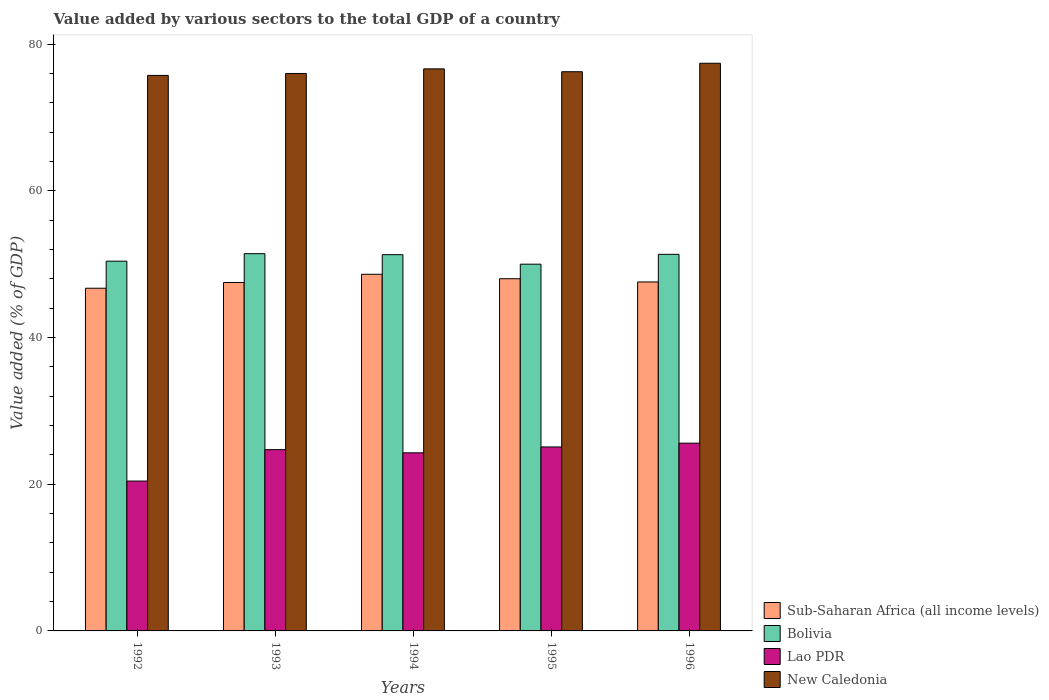How many different coloured bars are there?
Keep it short and to the point. 4. How many groups of bars are there?
Your answer should be very brief. 5. How many bars are there on the 1st tick from the right?
Make the answer very short. 4. What is the label of the 3rd group of bars from the left?
Keep it short and to the point. 1994. What is the value added by various sectors to the total GDP in Sub-Saharan Africa (all income levels) in 1995?
Offer a terse response. 48.02. Across all years, what is the maximum value added by various sectors to the total GDP in Lao PDR?
Provide a short and direct response. 25.6. Across all years, what is the minimum value added by various sectors to the total GDP in Bolivia?
Keep it short and to the point. 50. In which year was the value added by various sectors to the total GDP in New Caledonia maximum?
Offer a very short reply. 1996. In which year was the value added by various sectors to the total GDP in Lao PDR minimum?
Ensure brevity in your answer.  1992. What is the total value added by various sectors to the total GDP in Bolivia in the graph?
Keep it short and to the point. 254.5. What is the difference between the value added by various sectors to the total GDP in Bolivia in 1993 and that in 1995?
Your response must be concise. 1.43. What is the difference between the value added by various sectors to the total GDP in Lao PDR in 1994 and the value added by various sectors to the total GDP in New Caledonia in 1995?
Give a very brief answer. -51.96. What is the average value added by various sectors to the total GDP in Sub-Saharan Africa (all income levels) per year?
Your response must be concise. 47.69. In the year 1994, what is the difference between the value added by various sectors to the total GDP in Lao PDR and value added by various sectors to the total GDP in Bolivia?
Give a very brief answer. -27.02. In how many years, is the value added by various sectors to the total GDP in Bolivia greater than 76 %?
Offer a very short reply. 0. What is the ratio of the value added by various sectors to the total GDP in Lao PDR in 1994 to that in 1996?
Your response must be concise. 0.95. What is the difference between the highest and the second highest value added by various sectors to the total GDP in Sub-Saharan Africa (all income levels)?
Offer a terse response. 0.61. What is the difference between the highest and the lowest value added by various sectors to the total GDP in Sub-Saharan Africa (all income levels)?
Keep it short and to the point. 1.9. Is it the case that in every year, the sum of the value added by various sectors to the total GDP in New Caledonia and value added by various sectors to the total GDP in Lao PDR is greater than the sum of value added by various sectors to the total GDP in Sub-Saharan Africa (all income levels) and value added by various sectors to the total GDP in Bolivia?
Provide a short and direct response. No. What does the 4th bar from the left in 1994 represents?
Your response must be concise. New Caledonia. What does the 1st bar from the right in 1995 represents?
Provide a short and direct response. New Caledonia. Are all the bars in the graph horizontal?
Provide a succinct answer. No. What is the difference between two consecutive major ticks on the Y-axis?
Provide a succinct answer. 20. Does the graph contain any zero values?
Make the answer very short. No. How are the legend labels stacked?
Make the answer very short. Vertical. What is the title of the graph?
Your answer should be compact. Value added by various sectors to the total GDP of a country. What is the label or title of the Y-axis?
Provide a succinct answer. Value added (% of GDP). What is the Value added (% of GDP) in Sub-Saharan Africa (all income levels) in 1992?
Your answer should be very brief. 46.72. What is the Value added (% of GDP) in Bolivia in 1992?
Your answer should be very brief. 50.41. What is the Value added (% of GDP) in Lao PDR in 1992?
Offer a terse response. 20.43. What is the Value added (% of GDP) in New Caledonia in 1992?
Offer a very short reply. 75.74. What is the Value added (% of GDP) in Sub-Saharan Africa (all income levels) in 1993?
Give a very brief answer. 47.5. What is the Value added (% of GDP) of Bolivia in 1993?
Your answer should be compact. 51.44. What is the Value added (% of GDP) of Lao PDR in 1993?
Give a very brief answer. 24.72. What is the Value added (% of GDP) of New Caledonia in 1993?
Keep it short and to the point. 76. What is the Value added (% of GDP) in Sub-Saharan Africa (all income levels) in 1994?
Give a very brief answer. 48.63. What is the Value added (% of GDP) in Bolivia in 1994?
Make the answer very short. 51.3. What is the Value added (% of GDP) of Lao PDR in 1994?
Provide a short and direct response. 24.28. What is the Value added (% of GDP) of New Caledonia in 1994?
Offer a terse response. 76.63. What is the Value added (% of GDP) of Sub-Saharan Africa (all income levels) in 1995?
Offer a terse response. 48.02. What is the Value added (% of GDP) of Bolivia in 1995?
Provide a succinct answer. 50. What is the Value added (% of GDP) in Lao PDR in 1995?
Your answer should be compact. 25.08. What is the Value added (% of GDP) of New Caledonia in 1995?
Give a very brief answer. 76.24. What is the Value added (% of GDP) of Sub-Saharan Africa (all income levels) in 1996?
Offer a very short reply. 47.58. What is the Value added (% of GDP) of Bolivia in 1996?
Offer a very short reply. 51.35. What is the Value added (% of GDP) in Lao PDR in 1996?
Keep it short and to the point. 25.6. What is the Value added (% of GDP) of New Caledonia in 1996?
Provide a succinct answer. 77.4. Across all years, what is the maximum Value added (% of GDP) of Sub-Saharan Africa (all income levels)?
Your answer should be compact. 48.63. Across all years, what is the maximum Value added (% of GDP) in Bolivia?
Offer a terse response. 51.44. Across all years, what is the maximum Value added (% of GDP) of Lao PDR?
Provide a short and direct response. 25.6. Across all years, what is the maximum Value added (% of GDP) in New Caledonia?
Provide a succinct answer. 77.4. Across all years, what is the minimum Value added (% of GDP) in Sub-Saharan Africa (all income levels)?
Your response must be concise. 46.72. Across all years, what is the minimum Value added (% of GDP) in Bolivia?
Your answer should be very brief. 50. Across all years, what is the minimum Value added (% of GDP) of Lao PDR?
Your answer should be compact. 20.43. Across all years, what is the minimum Value added (% of GDP) of New Caledonia?
Make the answer very short. 75.74. What is the total Value added (% of GDP) of Sub-Saharan Africa (all income levels) in the graph?
Provide a short and direct response. 238.46. What is the total Value added (% of GDP) of Bolivia in the graph?
Offer a very short reply. 254.5. What is the total Value added (% of GDP) of Lao PDR in the graph?
Make the answer very short. 120.12. What is the total Value added (% of GDP) in New Caledonia in the graph?
Provide a short and direct response. 382.02. What is the difference between the Value added (% of GDP) of Sub-Saharan Africa (all income levels) in 1992 and that in 1993?
Your answer should be very brief. -0.78. What is the difference between the Value added (% of GDP) of Bolivia in 1992 and that in 1993?
Give a very brief answer. -1.02. What is the difference between the Value added (% of GDP) of Lao PDR in 1992 and that in 1993?
Make the answer very short. -4.28. What is the difference between the Value added (% of GDP) in New Caledonia in 1992 and that in 1993?
Your answer should be very brief. -0.26. What is the difference between the Value added (% of GDP) of Sub-Saharan Africa (all income levels) in 1992 and that in 1994?
Provide a succinct answer. -1.9. What is the difference between the Value added (% of GDP) in Bolivia in 1992 and that in 1994?
Give a very brief answer. -0.88. What is the difference between the Value added (% of GDP) of Lao PDR in 1992 and that in 1994?
Offer a terse response. -3.85. What is the difference between the Value added (% of GDP) in New Caledonia in 1992 and that in 1994?
Ensure brevity in your answer.  -0.89. What is the difference between the Value added (% of GDP) in Sub-Saharan Africa (all income levels) in 1992 and that in 1995?
Your answer should be compact. -1.3. What is the difference between the Value added (% of GDP) in Bolivia in 1992 and that in 1995?
Keep it short and to the point. 0.41. What is the difference between the Value added (% of GDP) in Lao PDR in 1992 and that in 1995?
Provide a short and direct response. -4.65. What is the difference between the Value added (% of GDP) of New Caledonia in 1992 and that in 1995?
Provide a succinct answer. -0.5. What is the difference between the Value added (% of GDP) of Sub-Saharan Africa (all income levels) in 1992 and that in 1996?
Provide a short and direct response. -0.86. What is the difference between the Value added (% of GDP) in Bolivia in 1992 and that in 1996?
Ensure brevity in your answer.  -0.93. What is the difference between the Value added (% of GDP) in Lao PDR in 1992 and that in 1996?
Offer a very short reply. -5.17. What is the difference between the Value added (% of GDP) of New Caledonia in 1992 and that in 1996?
Make the answer very short. -1.66. What is the difference between the Value added (% of GDP) of Sub-Saharan Africa (all income levels) in 1993 and that in 1994?
Offer a very short reply. -1.12. What is the difference between the Value added (% of GDP) of Bolivia in 1993 and that in 1994?
Make the answer very short. 0.14. What is the difference between the Value added (% of GDP) of Lao PDR in 1993 and that in 1994?
Give a very brief answer. 0.43. What is the difference between the Value added (% of GDP) in New Caledonia in 1993 and that in 1994?
Give a very brief answer. -0.63. What is the difference between the Value added (% of GDP) in Sub-Saharan Africa (all income levels) in 1993 and that in 1995?
Offer a very short reply. -0.52. What is the difference between the Value added (% of GDP) of Bolivia in 1993 and that in 1995?
Provide a succinct answer. 1.43. What is the difference between the Value added (% of GDP) of Lao PDR in 1993 and that in 1995?
Your answer should be very brief. -0.37. What is the difference between the Value added (% of GDP) in New Caledonia in 1993 and that in 1995?
Offer a terse response. -0.24. What is the difference between the Value added (% of GDP) of Sub-Saharan Africa (all income levels) in 1993 and that in 1996?
Make the answer very short. -0.08. What is the difference between the Value added (% of GDP) of Bolivia in 1993 and that in 1996?
Your response must be concise. 0.09. What is the difference between the Value added (% of GDP) in Lao PDR in 1993 and that in 1996?
Ensure brevity in your answer.  -0.88. What is the difference between the Value added (% of GDP) of New Caledonia in 1993 and that in 1996?
Provide a succinct answer. -1.39. What is the difference between the Value added (% of GDP) in Sub-Saharan Africa (all income levels) in 1994 and that in 1995?
Give a very brief answer. 0.61. What is the difference between the Value added (% of GDP) in Bolivia in 1994 and that in 1995?
Make the answer very short. 1.3. What is the difference between the Value added (% of GDP) in Lao PDR in 1994 and that in 1995?
Provide a succinct answer. -0.8. What is the difference between the Value added (% of GDP) in New Caledonia in 1994 and that in 1995?
Keep it short and to the point. 0.39. What is the difference between the Value added (% of GDP) in Sub-Saharan Africa (all income levels) in 1994 and that in 1996?
Your answer should be very brief. 1.05. What is the difference between the Value added (% of GDP) in Bolivia in 1994 and that in 1996?
Offer a very short reply. -0.05. What is the difference between the Value added (% of GDP) in Lao PDR in 1994 and that in 1996?
Give a very brief answer. -1.32. What is the difference between the Value added (% of GDP) in New Caledonia in 1994 and that in 1996?
Make the answer very short. -0.76. What is the difference between the Value added (% of GDP) in Sub-Saharan Africa (all income levels) in 1995 and that in 1996?
Keep it short and to the point. 0.44. What is the difference between the Value added (% of GDP) of Bolivia in 1995 and that in 1996?
Your answer should be very brief. -1.34. What is the difference between the Value added (% of GDP) in Lao PDR in 1995 and that in 1996?
Provide a succinct answer. -0.52. What is the difference between the Value added (% of GDP) of New Caledonia in 1995 and that in 1996?
Make the answer very short. -1.15. What is the difference between the Value added (% of GDP) in Sub-Saharan Africa (all income levels) in 1992 and the Value added (% of GDP) in Bolivia in 1993?
Provide a succinct answer. -4.71. What is the difference between the Value added (% of GDP) of Sub-Saharan Africa (all income levels) in 1992 and the Value added (% of GDP) of Lao PDR in 1993?
Your answer should be compact. 22.01. What is the difference between the Value added (% of GDP) of Sub-Saharan Africa (all income levels) in 1992 and the Value added (% of GDP) of New Caledonia in 1993?
Offer a very short reply. -29.28. What is the difference between the Value added (% of GDP) in Bolivia in 1992 and the Value added (% of GDP) in Lao PDR in 1993?
Make the answer very short. 25.7. What is the difference between the Value added (% of GDP) in Bolivia in 1992 and the Value added (% of GDP) in New Caledonia in 1993?
Offer a terse response. -25.59. What is the difference between the Value added (% of GDP) in Lao PDR in 1992 and the Value added (% of GDP) in New Caledonia in 1993?
Provide a short and direct response. -55.57. What is the difference between the Value added (% of GDP) of Sub-Saharan Africa (all income levels) in 1992 and the Value added (% of GDP) of Bolivia in 1994?
Provide a succinct answer. -4.58. What is the difference between the Value added (% of GDP) of Sub-Saharan Africa (all income levels) in 1992 and the Value added (% of GDP) of Lao PDR in 1994?
Give a very brief answer. 22.44. What is the difference between the Value added (% of GDP) of Sub-Saharan Africa (all income levels) in 1992 and the Value added (% of GDP) of New Caledonia in 1994?
Keep it short and to the point. -29.91. What is the difference between the Value added (% of GDP) of Bolivia in 1992 and the Value added (% of GDP) of Lao PDR in 1994?
Offer a very short reply. 26.13. What is the difference between the Value added (% of GDP) in Bolivia in 1992 and the Value added (% of GDP) in New Caledonia in 1994?
Provide a short and direct response. -26.22. What is the difference between the Value added (% of GDP) in Lao PDR in 1992 and the Value added (% of GDP) in New Caledonia in 1994?
Your answer should be very brief. -56.2. What is the difference between the Value added (% of GDP) in Sub-Saharan Africa (all income levels) in 1992 and the Value added (% of GDP) in Bolivia in 1995?
Your response must be concise. -3.28. What is the difference between the Value added (% of GDP) in Sub-Saharan Africa (all income levels) in 1992 and the Value added (% of GDP) in Lao PDR in 1995?
Your response must be concise. 21.64. What is the difference between the Value added (% of GDP) of Sub-Saharan Africa (all income levels) in 1992 and the Value added (% of GDP) of New Caledonia in 1995?
Provide a succinct answer. -29.52. What is the difference between the Value added (% of GDP) of Bolivia in 1992 and the Value added (% of GDP) of Lao PDR in 1995?
Provide a succinct answer. 25.33. What is the difference between the Value added (% of GDP) of Bolivia in 1992 and the Value added (% of GDP) of New Caledonia in 1995?
Give a very brief answer. -25.83. What is the difference between the Value added (% of GDP) in Lao PDR in 1992 and the Value added (% of GDP) in New Caledonia in 1995?
Offer a very short reply. -55.81. What is the difference between the Value added (% of GDP) of Sub-Saharan Africa (all income levels) in 1992 and the Value added (% of GDP) of Bolivia in 1996?
Keep it short and to the point. -4.62. What is the difference between the Value added (% of GDP) in Sub-Saharan Africa (all income levels) in 1992 and the Value added (% of GDP) in Lao PDR in 1996?
Your response must be concise. 21.12. What is the difference between the Value added (% of GDP) in Sub-Saharan Africa (all income levels) in 1992 and the Value added (% of GDP) in New Caledonia in 1996?
Offer a terse response. -30.67. What is the difference between the Value added (% of GDP) of Bolivia in 1992 and the Value added (% of GDP) of Lao PDR in 1996?
Your response must be concise. 24.81. What is the difference between the Value added (% of GDP) in Bolivia in 1992 and the Value added (% of GDP) in New Caledonia in 1996?
Offer a terse response. -26.98. What is the difference between the Value added (% of GDP) in Lao PDR in 1992 and the Value added (% of GDP) in New Caledonia in 1996?
Offer a very short reply. -56.96. What is the difference between the Value added (% of GDP) of Sub-Saharan Africa (all income levels) in 1993 and the Value added (% of GDP) of Bolivia in 1994?
Ensure brevity in your answer.  -3.8. What is the difference between the Value added (% of GDP) in Sub-Saharan Africa (all income levels) in 1993 and the Value added (% of GDP) in Lao PDR in 1994?
Offer a very short reply. 23.22. What is the difference between the Value added (% of GDP) of Sub-Saharan Africa (all income levels) in 1993 and the Value added (% of GDP) of New Caledonia in 1994?
Keep it short and to the point. -29.13. What is the difference between the Value added (% of GDP) of Bolivia in 1993 and the Value added (% of GDP) of Lao PDR in 1994?
Provide a succinct answer. 27.15. What is the difference between the Value added (% of GDP) of Bolivia in 1993 and the Value added (% of GDP) of New Caledonia in 1994?
Give a very brief answer. -25.2. What is the difference between the Value added (% of GDP) of Lao PDR in 1993 and the Value added (% of GDP) of New Caledonia in 1994?
Offer a very short reply. -51.92. What is the difference between the Value added (% of GDP) in Sub-Saharan Africa (all income levels) in 1993 and the Value added (% of GDP) in Bolivia in 1995?
Your answer should be very brief. -2.5. What is the difference between the Value added (% of GDP) of Sub-Saharan Africa (all income levels) in 1993 and the Value added (% of GDP) of Lao PDR in 1995?
Keep it short and to the point. 22.42. What is the difference between the Value added (% of GDP) in Sub-Saharan Africa (all income levels) in 1993 and the Value added (% of GDP) in New Caledonia in 1995?
Make the answer very short. -28.74. What is the difference between the Value added (% of GDP) in Bolivia in 1993 and the Value added (% of GDP) in Lao PDR in 1995?
Ensure brevity in your answer.  26.35. What is the difference between the Value added (% of GDP) of Bolivia in 1993 and the Value added (% of GDP) of New Caledonia in 1995?
Provide a short and direct response. -24.81. What is the difference between the Value added (% of GDP) in Lao PDR in 1993 and the Value added (% of GDP) in New Caledonia in 1995?
Keep it short and to the point. -51.53. What is the difference between the Value added (% of GDP) in Sub-Saharan Africa (all income levels) in 1993 and the Value added (% of GDP) in Bolivia in 1996?
Offer a terse response. -3.84. What is the difference between the Value added (% of GDP) of Sub-Saharan Africa (all income levels) in 1993 and the Value added (% of GDP) of Lao PDR in 1996?
Your response must be concise. 21.9. What is the difference between the Value added (% of GDP) of Sub-Saharan Africa (all income levels) in 1993 and the Value added (% of GDP) of New Caledonia in 1996?
Give a very brief answer. -29.89. What is the difference between the Value added (% of GDP) of Bolivia in 1993 and the Value added (% of GDP) of Lao PDR in 1996?
Offer a very short reply. 25.84. What is the difference between the Value added (% of GDP) of Bolivia in 1993 and the Value added (% of GDP) of New Caledonia in 1996?
Keep it short and to the point. -25.96. What is the difference between the Value added (% of GDP) in Lao PDR in 1993 and the Value added (% of GDP) in New Caledonia in 1996?
Make the answer very short. -52.68. What is the difference between the Value added (% of GDP) in Sub-Saharan Africa (all income levels) in 1994 and the Value added (% of GDP) in Bolivia in 1995?
Your response must be concise. -1.38. What is the difference between the Value added (% of GDP) of Sub-Saharan Africa (all income levels) in 1994 and the Value added (% of GDP) of Lao PDR in 1995?
Your answer should be compact. 23.54. What is the difference between the Value added (% of GDP) of Sub-Saharan Africa (all income levels) in 1994 and the Value added (% of GDP) of New Caledonia in 1995?
Your answer should be very brief. -27.62. What is the difference between the Value added (% of GDP) of Bolivia in 1994 and the Value added (% of GDP) of Lao PDR in 1995?
Give a very brief answer. 26.22. What is the difference between the Value added (% of GDP) of Bolivia in 1994 and the Value added (% of GDP) of New Caledonia in 1995?
Provide a short and direct response. -24.94. What is the difference between the Value added (% of GDP) of Lao PDR in 1994 and the Value added (% of GDP) of New Caledonia in 1995?
Give a very brief answer. -51.96. What is the difference between the Value added (% of GDP) of Sub-Saharan Africa (all income levels) in 1994 and the Value added (% of GDP) of Bolivia in 1996?
Give a very brief answer. -2.72. What is the difference between the Value added (% of GDP) in Sub-Saharan Africa (all income levels) in 1994 and the Value added (% of GDP) in Lao PDR in 1996?
Keep it short and to the point. 23.03. What is the difference between the Value added (% of GDP) of Sub-Saharan Africa (all income levels) in 1994 and the Value added (% of GDP) of New Caledonia in 1996?
Give a very brief answer. -28.77. What is the difference between the Value added (% of GDP) of Bolivia in 1994 and the Value added (% of GDP) of Lao PDR in 1996?
Your response must be concise. 25.7. What is the difference between the Value added (% of GDP) in Bolivia in 1994 and the Value added (% of GDP) in New Caledonia in 1996?
Provide a short and direct response. -26.1. What is the difference between the Value added (% of GDP) in Lao PDR in 1994 and the Value added (% of GDP) in New Caledonia in 1996?
Provide a short and direct response. -53.11. What is the difference between the Value added (% of GDP) in Sub-Saharan Africa (all income levels) in 1995 and the Value added (% of GDP) in Bolivia in 1996?
Provide a succinct answer. -3.33. What is the difference between the Value added (% of GDP) in Sub-Saharan Africa (all income levels) in 1995 and the Value added (% of GDP) in Lao PDR in 1996?
Your answer should be compact. 22.42. What is the difference between the Value added (% of GDP) of Sub-Saharan Africa (all income levels) in 1995 and the Value added (% of GDP) of New Caledonia in 1996?
Give a very brief answer. -29.38. What is the difference between the Value added (% of GDP) of Bolivia in 1995 and the Value added (% of GDP) of Lao PDR in 1996?
Ensure brevity in your answer.  24.4. What is the difference between the Value added (% of GDP) of Bolivia in 1995 and the Value added (% of GDP) of New Caledonia in 1996?
Ensure brevity in your answer.  -27.39. What is the difference between the Value added (% of GDP) in Lao PDR in 1995 and the Value added (% of GDP) in New Caledonia in 1996?
Ensure brevity in your answer.  -52.31. What is the average Value added (% of GDP) of Sub-Saharan Africa (all income levels) per year?
Give a very brief answer. 47.69. What is the average Value added (% of GDP) of Bolivia per year?
Provide a succinct answer. 50.9. What is the average Value added (% of GDP) in Lao PDR per year?
Make the answer very short. 24.02. What is the average Value added (% of GDP) of New Caledonia per year?
Your response must be concise. 76.4. In the year 1992, what is the difference between the Value added (% of GDP) of Sub-Saharan Africa (all income levels) and Value added (% of GDP) of Bolivia?
Your answer should be very brief. -3.69. In the year 1992, what is the difference between the Value added (% of GDP) of Sub-Saharan Africa (all income levels) and Value added (% of GDP) of Lao PDR?
Your answer should be compact. 26.29. In the year 1992, what is the difference between the Value added (% of GDP) in Sub-Saharan Africa (all income levels) and Value added (% of GDP) in New Caledonia?
Offer a terse response. -29.02. In the year 1992, what is the difference between the Value added (% of GDP) of Bolivia and Value added (% of GDP) of Lao PDR?
Provide a short and direct response. 29.98. In the year 1992, what is the difference between the Value added (% of GDP) in Bolivia and Value added (% of GDP) in New Caledonia?
Provide a succinct answer. -25.33. In the year 1992, what is the difference between the Value added (% of GDP) of Lao PDR and Value added (% of GDP) of New Caledonia?
Make the answer very short. -55.31. In the year 1993, what is the difference between the Value added (% of GDP) of Sub-Saharan Africa (all income levels) and Value added (% of GDP) of Bolivia?
Ensure brevity in your answer.  -3.93. In the year 1993, what is the difference between the Value added (% of GDP) of Sub-Saharan Africa (all income levels) and Value added (% of GDP) of Lao PDR?
Your answer should be compact. 22.79. In the year 1993, what is the difference between the Value added (% of GDP) of Sub-Saharan Africa (all income levels) and Value added (% of GDP) of New Caledonia?
Give a very brief answer. -28.5. In the year 1993, what is the difference between the Value added (% of GDP) of Bolivia and Value added (% of GDP) of Lao PDR?
Your answer should be very brief. 26.72. In the year 1993, what is the difference between the Value added (% of GDP) of Bolivia and Value added (% of GDP) of New Caledonia?
Give a very brief answer. -24.57. In the year 1993, what is the difference between the Value added (% of GDP) of Lao PDR and Value added (% of GDP) of New Caledonia?
Provide a short and direct response. -51.29. In the year 1994, what is the difference between the Value added (% of GDP) of Sub-Saharan Africa (all income levels) and Value added (% of GDP) of Bolivia?
Offer a terse response. -2.67. In the year 1994, what is the difference between the Value added (% of GDP) in Sub-Saharan Africa (all income levels) and Value added (% of GDP) in Lao PDR?
Make the answer very short. 24.34. In the year 1994, what is the difference between the Value added (% of GDP) in Sub-Saharan Africa (all income levels) and Value added (% of GDP) in New Caledonia?
Keep it short and to the point. -28.01. In the year 1994, what is the difference between the Value added (% of GDP) of Bolivia and Value added (% of GDP) of Lao PDR?
Keep it short and to the point. 27.02. In the year 1994, what is the difference between the Value added (% of GDP) in Bolivia and Value added (% of GDP) in New Caledonia?
Your answer should be very brief. -25.33. In the year 1994, what is the difference between the Value added (% of GDP) in Lao PDR and Value added (% of GDP) in New Caledonia?
Give a very brief answer. -52.35. In the year 1995, what is the difference between the Value added (% of GDP) of Sub-Saharan Africa (all income levels) and Value added (% of GDP) of Bolivia?
Keep it short and to the point. -1.98. In the year 1995, what is the difference between the Value added (% of GDP) in Sub-Saharan Africa (all income levels) and Value added (% of GDP) in Lao PDR?
Provide a succinct answer. 22.94. In the year 1995, what is the difference between the Value added (% of GDP) in Sub-Saharan Africa (all income levels) and Value added (% of GDP) in New Caledonia?
Provide a short and direct response. -28.22. In the year 1995, what is the difference between the Value added (% of GDP) in Bolivia and Value added (% of GDP) in Lao PDR?
Offer a terse response. 24.92. In the year 1995, what is the difference between the Value added (% of GDP) in Bolivia and Value added (% of GDP) in New Caledonia?
Your answer should be very brief. -26.24. In the year 1995, what is the difference between the Value added (% of GDP) in Lao PDR and Value added (% of GDP) in New Caledonia?
Provide a succinct answer. -51.16. In the year 1996, what is the difference between the Value added (% of GDP) of Sub-Saharan Africa (all income levels) and Value added (% of GDP) of Bolivia?
Offer a very short reply. -3.77. In the year 1996, what is the difference between the Value added (% of GDP) in Sub-Saharan Africa (all income levels) and Value added (% of GDP) in Lao PDR?
Offer a terse response. 21.98. In the year 1996, what is the difference between the Value added (% of GDP) of Sub-Saharan Africa (all income levels) and Value added (% of GDP) of New Caledonia?
Your answer should be very brief. -29.82. In the year 1996, what is the difference between the Value added (% of GDP) in Bolivia and Value added (% of GDP) in Lao PDR?
Offer a very short reply. 25.75. In the year 1996, what is the difference between the Value added (% of GDP) in Bolivia and Value added (% of GDP) in New Caledonia?
Give a very brief answer. -26.05. In the year 1996, what is the difference between the Value added (% of GDP) of Lao PDR and Value added (% of GDP) of New Caledonia?
Make the answer very short. -51.8. What is the ratio of the Value added (% of GDP) of Sub-Saharan Africa (all income levels) in 1992 to that in 1993?
Give a very brief answer. 0.98. What is the ratio of the Value added (% of GDP) in Bolivia in 1992 to that in 1993?
Ensure brevity in your answer.  0.98. What is the ratio of the Value added (% of GDP) in Lao PDR in 1992 to that in 1993?
Provide a short and direct response. 0.83. What is the ratio of the Value added (% of GDP) in New Caledonia in 1992 to that in 1993?
Your answer should be very brief. 1. What is the ratio of the Value added (% of GDP) in Sub-Saharan Africa (all income levels) in 1992 to that in 1994?
Give a very brief answer. 0.96. What is the ratio of the Value added (% of GDP) of Bolivia in 1992 to that in 1994?
Keep it short and to the point. 0.98. What is the ratio of the Value added (% of GDP) in Lao PDR in 1992 to that in 1994?
Provide a short and direct response. 0.84. What is the ratio of the Value added (% of GDP) of New Caledonia in 1992 to that in 1994?
Ensure brevity in your answer.  0.99. What is the ratio of the Value added (% of GDP) in Sub-Saharan Africa (all income levels) in 1992 to that in 1995?
Keep it short and to the point. 0.97. What is the ratio of the Value added (% of GDP) in Bolivia in 1992 to that in 1995?
Your answer should be compact. 1.01. What is the ratio of the Value added (% of GDP) of Lao PDR in 1992 to that in 1995?
Your answer should be compact. 0.81. What is the ratio of the Value added (% of GDP) in New Caledonia in 1992 to that in 1995?
Your answer should be very brief. 0.99. What is the ratio of the Value added (% of GDP) of Sub-Saharan Africa (all income levels) in 1992 to that in 1996?
Give a very brief answer. 0.98. What is the ratio of the Value added (% of GDP) in Bolivia in 1992 to that in 1996?
Offer a very short reply. 0.98. What is the ratio of the Value added (% of GDP) in Lao PDR in 1992 to that in 1996?
Your answer should be very brief. 0.8. What is the ratio of the Value added (% of GDP) of New Caledonia in 1992 to that in 1996?
Your response must be concise. 0.98. What is the ratio of the Value added (% of GDP) in Sub-Saharan Africa (all income levels) in 1993 to that in 1994?
Provide a succinct answer. 0.98. What is the ratio of the Value added (% of GDP) of Bolivia in 1993 to that in 1994?
Offer a very short reply. 1. What is the ratio of the Value added (% of GDP) in Lao PDR in 1993 to that in 1994?
Provide a short and direct response. 1.02. What is the ratio of the Value added (% of GDP) of New Caledonia in 1993 to that in 1994?
Your answer should be very brief. 0.99. What is the ratio of the Value added (% of GDP) of Sub-Saharan Africa (all income levels) in 1993 to that in 1995?
Keep it short and to the point. 0.99. What is the ratio of the Value added (% of GDP) of Bolivia in 1993 to that in 1995?
Your response must be concise. 1.03. What is the ratio of the Value added (% of GDP) of Lao PDR in 1993 to that in 1995?
Offer a terse response. 0.99. What is the ratio of the Value added (% of GDP) in Sub-Saharan Africa (all income levels) in 1993 to that in 1996?
Your answer should be very brief. 1. What is the ratio of the Value added (% of GDP) in Lao PDR in 1993 to that in 1996?
Offer a terse response. 0.97. What is the ratio of the Value added (% of GDP) of New Caledonia in 1993 to that in 1996?
Your response must be concise. 0.98. What is the ratio of the Value added (% of GDP) in Sub-Saharan Africa (all income levels) in 1994 to that in 1995?
Your response must be concise. 1.01. What is the ratio of the Value added (% of GDP) in Bolivia in 1994 to that in 1995?
Ensure brevity in your answer.  1.03. What is the ratio of the Value added (% of GDP) of Lao PDR in 1994 to that in 1995?
Keep it short and to the point. 0.97. What is the ratio of the Value added (% of GDP) of New Caledonia in 1994 to that in 1995?
Ensure brevity in your answer.  1.01. What is the ratio of the Value added (% of GDP) of Lao PDR in 1994 to that in 1996?
Make the answer very short. 0.95. What is the ratio of the Value added (% of GDP) of Sub-Saharan Africa (all income levels) in 1995 to that in 1996?
Your answer should be very brief. 1.01. What is the ratio of the Value added (% of GDP) in Bolivia in 1995 to that in 1996?
Offer a very short reply. 0.97. What is the ratio of the Value added (% of GDP) in Lao PDR in 1995 to that in 1996?
Provide a short and direct response. 0.98. What is the ratio of the Value added (% of GDP) in New Caledonia in 1995 to that in 1996?
Provide a short and direct response. 0.99. What is the difference between the highest and the second highest Value added (% of GDP) in Sub-Saharan Africa (all income levels)?
Offer a very short reply. 0.61. What is the difference between the highest and the second highest Value added (% of GDP) of Bolivia?
Your response must be concise. 0.09. What is the difference between the highest and the second highest Value added (% of GDP) of Lao PDR?
Give a very brief answer. 0.52. What is the difference between the highest and the second highest Value added (% of GDP) of New Caledonia?
Ensure brevity in your answer.  0.76. What is the difference between the highest and the lowest Value added (% of GDP) in Sub-Saharan Africa (all income levels)?
Ensure brevity in your answer.  1.9. What is the difference between the highest and the lowest Value added (% of GDP) in Bolivia?
Give a very brief answer. 1.43. What is the difference between the highest and the lowest Value added (% of GDP) in Lao PDR?
Ensure brevity in your answer.  5.17. What is the difference between the highest and the lowest Value added (% of GDP) of New Caledonia?
Offer a very short reply. 1.66. 